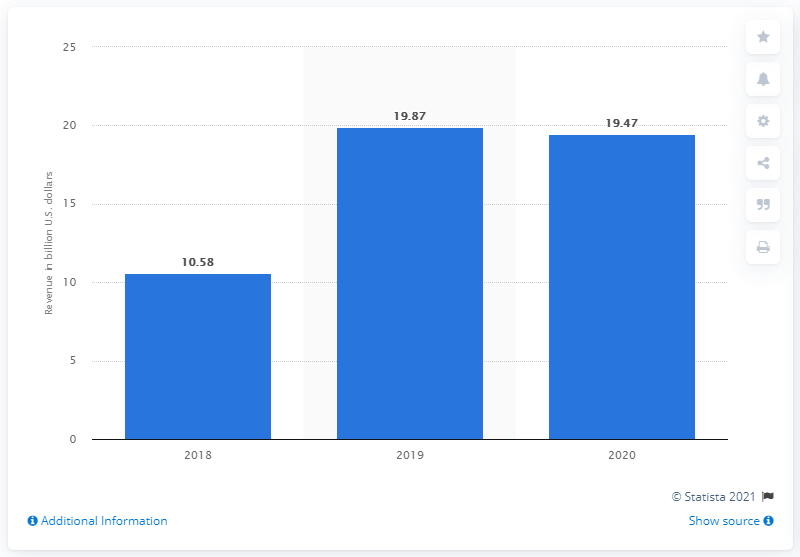Indicate a few pertinent items in this graphic. In 2020, WarnerMedia generated 19.47... 